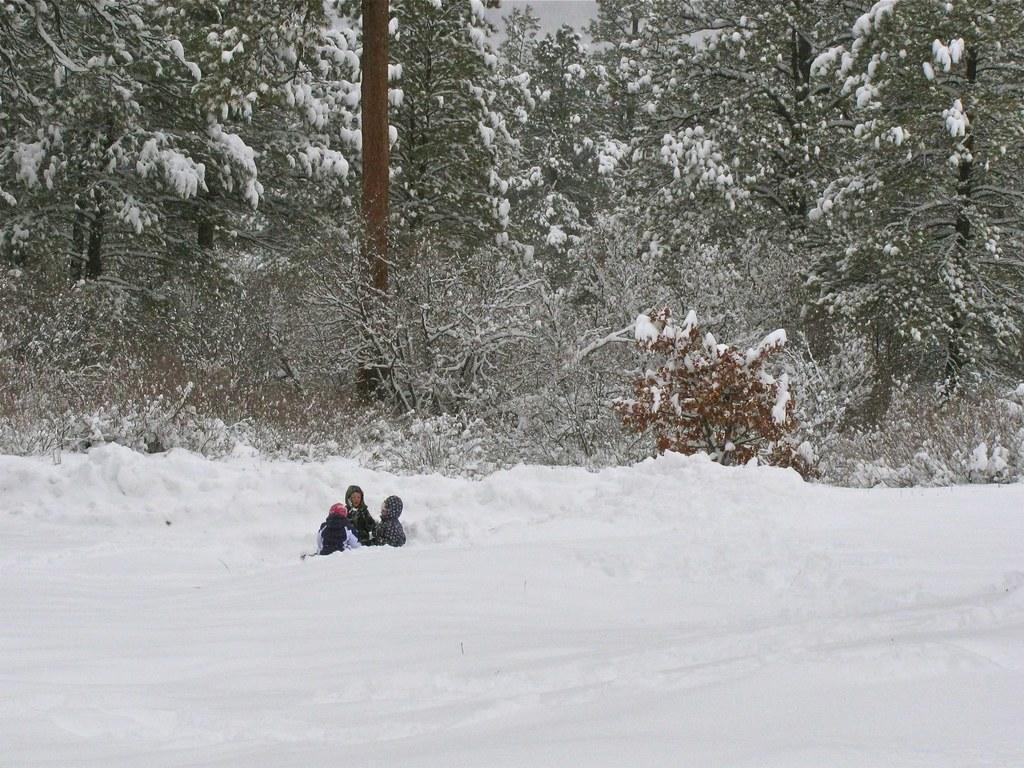Please provide a concise description of this image. There is a thick snow and there are two people laying on the snow, behind them there are a lot of trees and they are also covered with ice. 